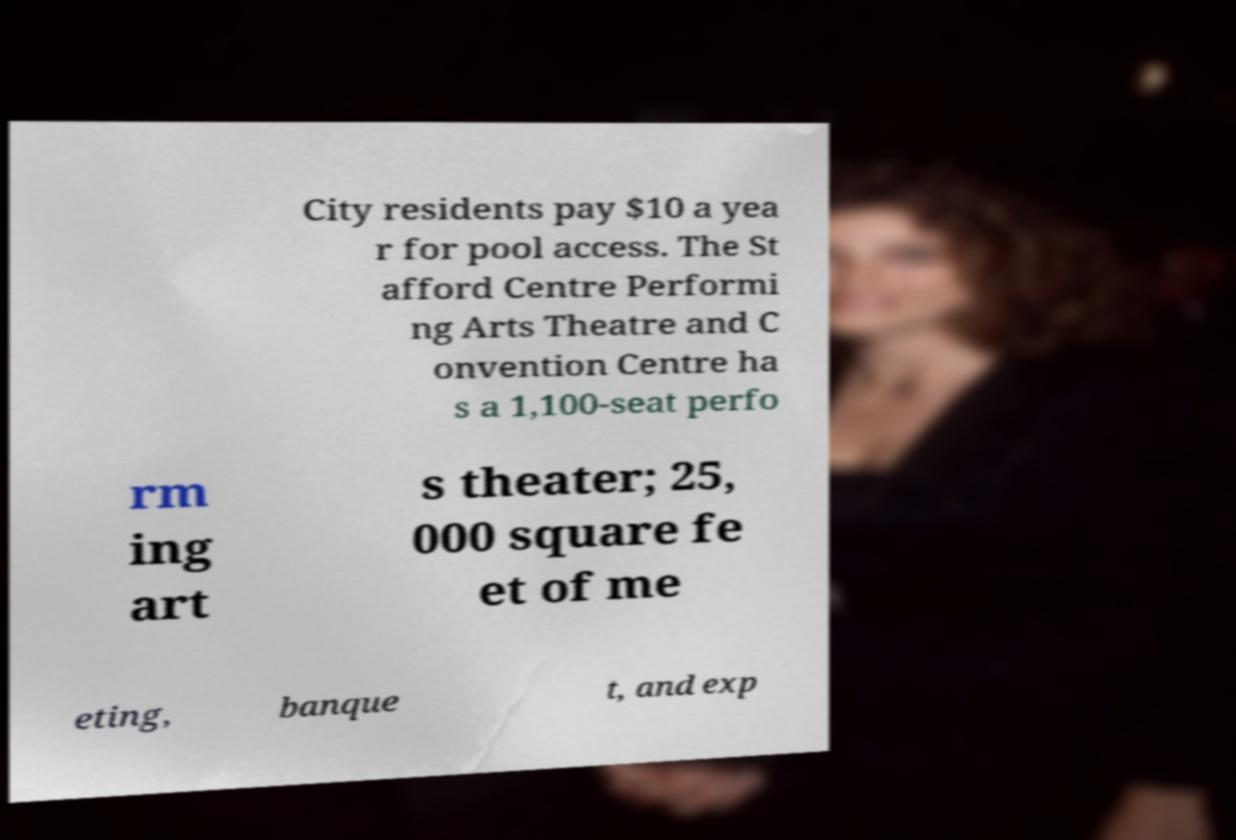Can you accurately transcribe the text from the provided image for me? City residents pay $10 a yea r for pool access. The St afford Centre Performi ng Arts Theatre and C onvention Centre ha s a 1,100-seat perfo rm ing art s theater; 25, 000 square fe et of me eting, banque t, and exp 